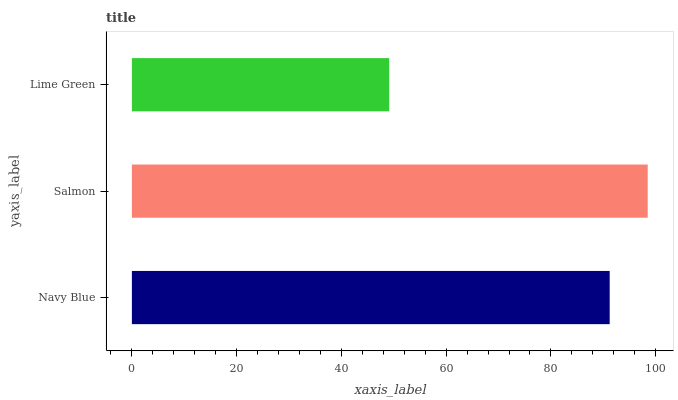Is Lime Green the minimum?
Answer yes or no. Yes. Is Salmon the maximum?
Answer yes or no. Yes. Is Salmon the minimum?
Answer yes or no. No. Is Lime Green the maximum?
Answer yes or no. No. Is Salmon greater than Lime Green?
Answer yes or no. Yes. Is Lime Green less than Salmon?
Answer yes or no. Yes. Is Lime Green greater than Salmon?
Answer yes or no. No. Is Salmon less than Lime Green?
Answer yes or no. No. Is Navy Blue the high median?
Answer yes or no. Yes. Is Navy Blue the low median?
Answer yes or no. Yes. Is Lime Green the high median?
Answer yes or no. No. Is Salmon the low median?
Answer yes or no. No. 